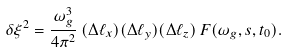<formula> <loc_0><loc_0><loc_500><loc_500>\delta \xi ^ { 2 } = \frac { \omega _ { g } ^ { 3 } } { 4 \pi ^ { 2 } } \, ( \Delta \ell _ { x } ) ( \Delta \ell _ { y } ) ( \Delta \ell _ { z } ) \, F ( \omega _ { g } , s , t _ { 0 } ) .</formula> 